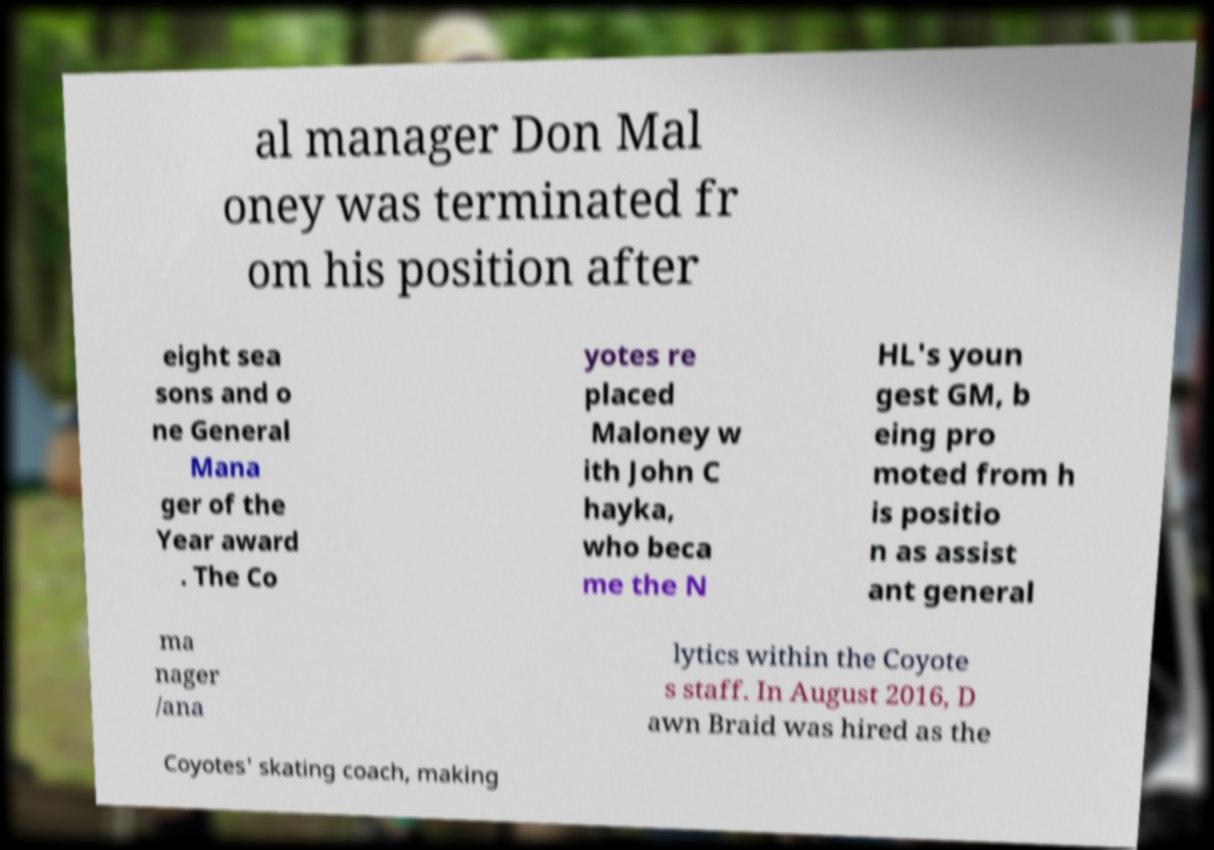There's text embedded in this image that I need extracted. Can you transcribe it verbatim? al manager Don Mal oney was terminated fr om his position after eight sea sons and o ne General Mana ger of the Year award . The Co yotes re placed Maloney w ith John C hayka, who beca me the N HL's youn gest GM, b eing pro moted from h is positio n as assist ant general ma nager /ana lytics within the Coyote s staff. In August 2016, D awn Braid was hired as the Coyotes' skating coach, making 